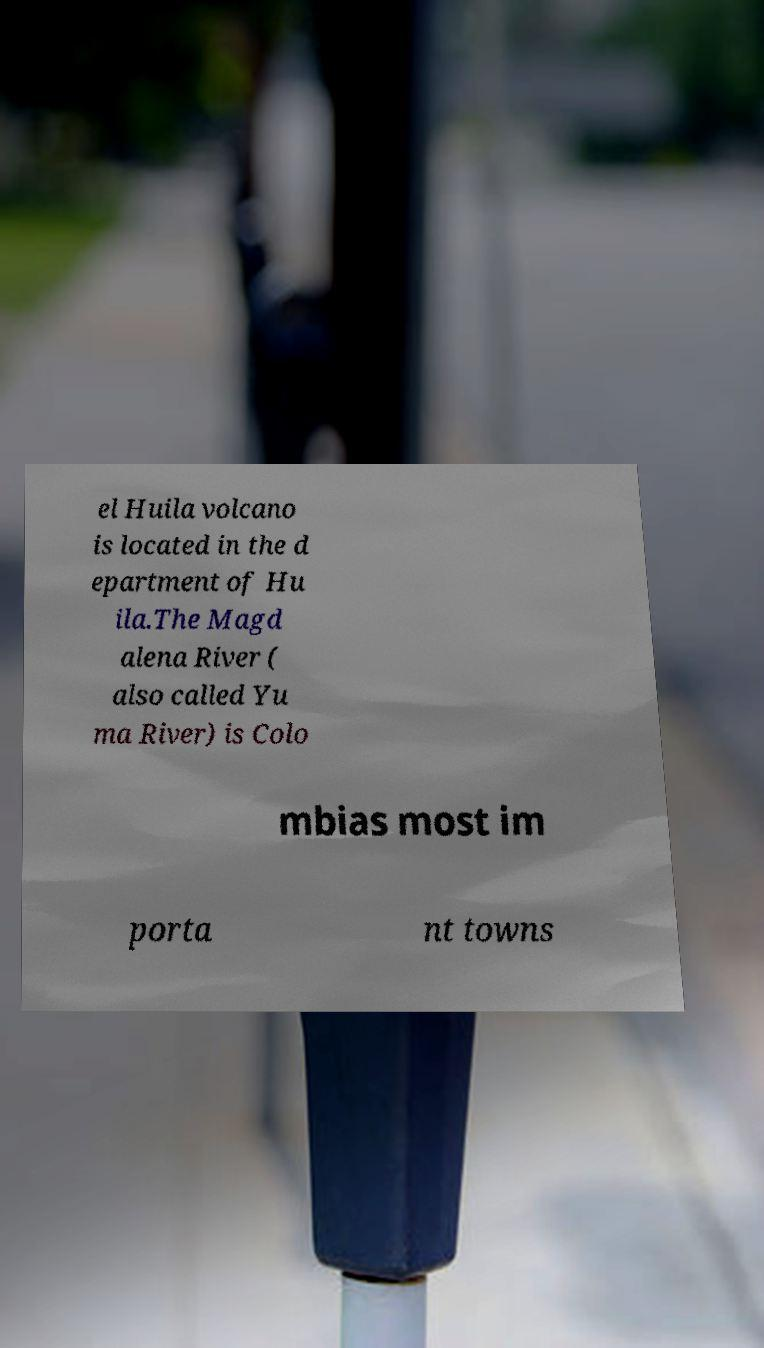Can you accurately transcribe the text from the provided image for me? el Huila volcano is located in the d epartment of Hu ila.The Magd alena River ( also called Yu ma River) is Colo mbias most im porta nt towns 